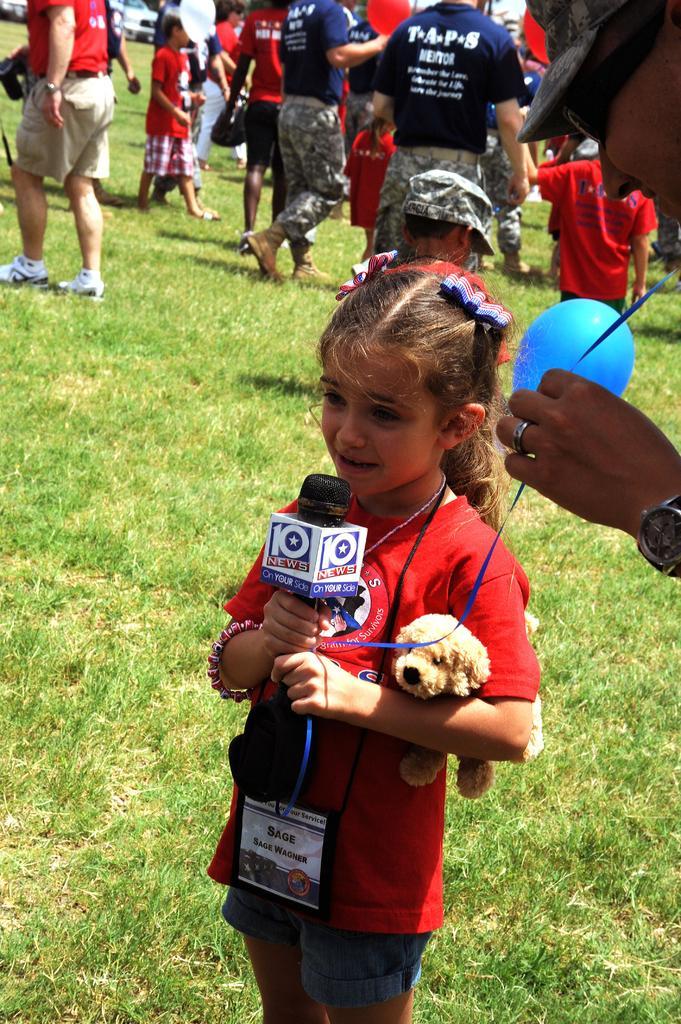Could you give a brief overview of what you see in this image? In the center of the image we can see girl standing and holding a mic. On the right side of the image we can see person standing and holding balloon. In the background we can see grass, persons and grass. 